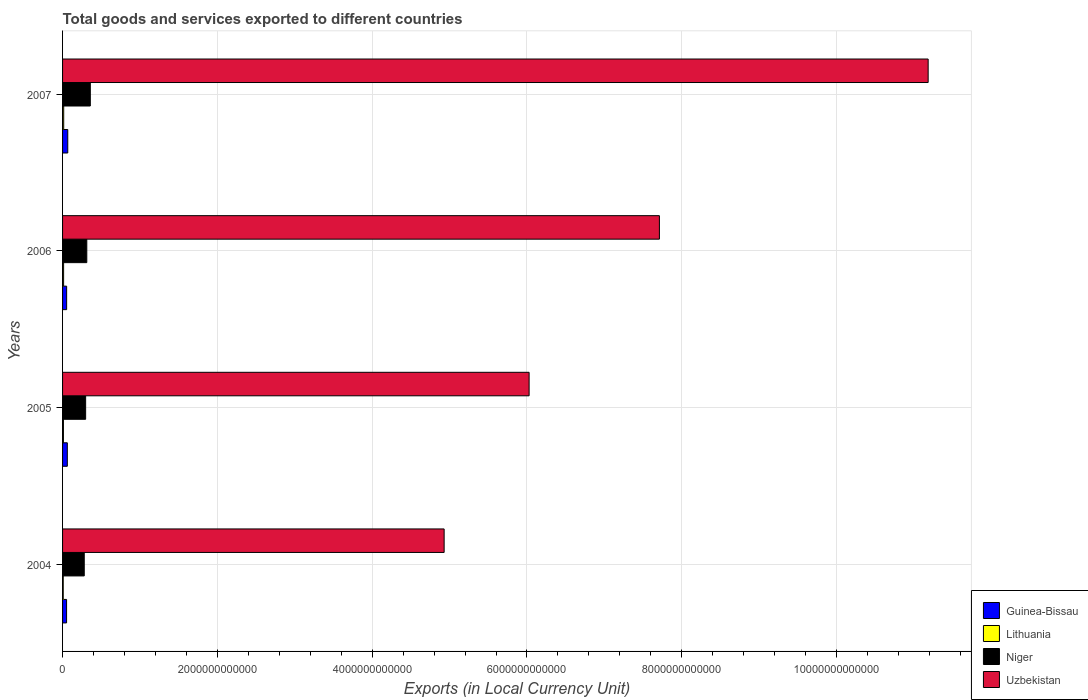Are the number of bars on each tick of the Y-axis equal?
Provide a succinct answer. Yes. How many bars are there on the 2nd tick from the bottom?
Ensure brevity in your answer.  4. What is the label of the 2nd group of bars from the top?
Offer a very short reply. 2006. What is the Amount of goods and services exports in Uzbekistan in 2007?
Your answer should be compact. 1.12e+13. Across all years, what is the maximum Amount of goods and services exports in Lithuania?
Offer a very short reply. 1.46e+1. Across all years, what is the minimum Amount of goods and services exports in Uzbekistan?
Your response must be concise. 4.93e+12. In which year was the Amount of goods and services exports in Lithuania maximum?
Your answer should be very brief. 2007. What is the total Amount of goods and services exports in Uzbekistan in the graph?
Provide a succinct answer. 2.99e+13. What is the difference between the Amount of goods and services exports in Uzbekistan in 2004 and that in 2007?
Your answer should be compact. -6.25e+12. What is the difference between the Amount of goods and services exports in Niger in 2004 and the Amount of goods and services exports in Guinea-Bissau in 2006?
Offer a terse response. 2.27e+11. What is the average Amount of goods and services exports in Uzbekistan per year?
Provide a short and direct response. 7.46e+12. In the year 2006, what is the difference between the Amount of goods and services exports in Guinea-Bissau and Amount of goods and services exports in Uzbekistan?
Make the answer very short. -7.66e+12. In how many years, is the Amount of goods and services exports in Lithuania greater than 9200000000000 LCU?
Your answer should be compact. 0. What is the ratio of the Amount of goods and services exports in Lithuania in 2004 to that in 2005?
Provide a short and direct response. 0.76. Is the Amount of goods and services exports in Niger in 2004 less than that in 2006?
Your answer should be very brief. Yes. Is the difference between the Amount of goods and services exports in Guinea-Bissau in 2005 and 2006 greater than the difference between the Amount of goods and services exports in Uzbekistan in 2005 and 2006?
Provide a short and direct response. Yes. What is the difference between the highest and the second highest Amount of goods and services exports in Uzbekistan?
Provide a short and direct response. 3.47e+12. What is the difference between the highest and the lowest Amount of goods and services exports in Lithuania?
Your answer should be very brief. 6.00e+09. In how many years, is the Amount of goods and services exports in Uzbekistan greater than the average Amount of goods and services exports in Uzbekistan taken over all years?
Offer a terse response. 2. Is the sum of the Amount of goods and services exports in Niger in 2006 and 2007 greater than the maximum Amount of goods and services exports in Uzbekistan across all years?
Ensure brevity in your answer.  No. Is it the case that in every year, the sum of the Amount of goods and services exports in Uzbekistan and Amount of goods and services exports in Guinea-Bissau is greater than the sum of Amount of goods and services exports in Niger and Amount of goods and services exports in Lithuania?
Your answer should be very brief. No. What does the 2nd bar from the top in 2005 represents?
Give a very brief answer. Niger. What does the 2nd bar from the bottom in 2006 represents?
Provide a succinct answer. Lithuania. How many years are there in the graph?
Keep it short and to the point. 4. What is the difference between two consecutive major ticks on the X-axis?
Your response must be concise. 2.00e+12. Does the graph contain any zero values?
Your answer should be compact. No. Does the graph contain grids?
Your answer should be very brief. Yes. Where does the legend appear in the graph?
Keep it short and to the point. Bottom right. What is the title of the graph?
Your answer should be compact. Total goods and services exported to different countries. Does "Mozambique" appear as one of the legend labels in the graph?
Provide a short and direct response. No. What is the label or title of the X-axis?
Offer a terse response. Exports (in Local Currency Unit). What is the Exports (in Local Currency Unit) of Guinea-Bissau in 2004?
Provide a succinct answer. 5.18e+1. What is the Exports (in Local Currency Unit) of Lithuania in 2004?
Keep it short and to the point. 8.64e+09. What is the Exports (in Local Currency Unit) in Niger in 2004?
Give a very brief answer. 2.80e+11. What is the Exports (in Local Currency Unit) of Uzbekistan in 2004?
Your answer should be compact. 4.93e+12. What is the Exports (in Local Currency Unit) in Guinea-Bissau in 2005?
Your answer should be very brief. 6.15e+1. What is the Exports (in Local Currency Unit) of Lithuania in 2005?
Your answer should be compact. 1.13e+1. What is the Exports (in Local Currency Unit) in Niger in 2005?
Offer a terse response. 2.98e+11. What is the Exports (in Local Currency Unit) in Uzbekistan in 2005?
Give a very brief answer. 6.03e+12. What is the Exports (in Local Currency Unit) in Guinea-Bissau in 2006?
Offer a very short reply. 5.27e+1. What is the Exports (in Local Currency Unit) in Lithuania in 2006?
Offer a very short reply. 1.34e+1. What is the Exports (in Local Currency Unit) of Niger in 2006?
Your answer should be very brief. 3.13e+11. What is the Exports (in Local Currency Unit) of Uzbekistan in 2006?
Your answer should be very brief. 7.71e+12. What is the Exports (in Local Currency Unit) of Guinea-Bissau in 2007?
Your response must be concise. 6.73e+1. What is the Exports (in Local Currency Unit) in Lithuania in 2007?
Keep it short and to the point. 1.46e+1. What is the Exports (in Local Currency Unit) in Niger in 2007?
Ensure brevity in your answer.  3.58e+11. What is the Exports (in Local Currency Unit) of Uzbekistan in 2007?
Your response must be concise. 1.12e+13. Across all years, what is the maximum Exports (in Local Currency Unit) of Guinea-Bissau?
Your answer should be compact. 6.73e+1. Across all years, what is the maximum Exports (in Local Currency Unit) in Lithuania?
Your answer should be very brief. 1.46e+1. Across all years, what is the maximum Exports (in Local Currency Unit) in Niger?
Ensure brevity in your answer.  3.58e+11. Across all years, what is the maximum Exports (in Local Currency Unit) of Uzbekistan?
Keep it short and to the point. 1.12e+13. Across all years, what is the minimum Exports (in Local Currency Unit) of Guinea-Bissau?
Provide a succinct answer. 5.18e+1. Across all years, what is the minimum Exports (in Local Currency Unit) of Lithuania?
Provide a succinct answer. 8.64e+09. Across all years, what is the minimum Exports (in Local Currency Unit) in Niger?
Your response must be concise. 2.80e+11. Across all years, what is the minimum Exports (in Local Currency Unit) of Uzbekistan?
Offer a terse response. 4.93e+12. What is the total Exports (in Local Currency Unit) of Guinea-Bissau in the graph?
Provide a succinct answer. 2.33e+11. What is the total Exports (in Local Currency Unit) of Lithuania in the graph?
Make the answer very short. 4.80e+1. What is the total Exports (in Local Currency Unit) of Niger in the graph?
Your response must be concise. 1.25e+12. What is the total Exports (in Local Currency Unit) of Uzbekistan in the graph?
Provide a short and direct response. 2.99e+13. What is the difference between the Exports (in Local Currency Unit) of Guinea-Bissau in 2004 and that in 2005?
Give a very brief answer. -9.66e+09. What is the difference between the Exports (in Local Currency Unit) in Lithuania in 2004 and that in 2005?
Your answer should be compact. -2.68e+09. What is the difference between the Exports (in Local Currency Unit) of Niger in 2004 and that in 2005?
Give a very brief answer. -1.80e+1. What is the difference between the Exports (in Local Currency Unit) in Uzbekistan in 2004 and that in 2005?
Your answer should be very brief. -1.10e+12. What is the difference between the Exports (in Local Currency Unit) of Guinea-Bissau in 2004 and that in 2006?
Make the answer very short. -9.06e+08. What is the difference between the Exports (in Local Currency Unit) of Lithuania in 2004 and that in 2006?
Your answer should be compact. -4.77e+09. What is the difference between the Exports (in Local Currency Unit) of Niger in 2004 and that in 2006?
Offer a terse response. -3.29e+1. What is the difference between the Exports (in Local Currency Unit) in Uzbekistan in 2004 and that in 2006?
Offer a very short reply. -2.78e+12. What is the difference between the Exports (in Local Currency Unit) of Guinea-Bissau in 2004 and that in 2007?
Provide a succinct answer. -1.55e+1. What is the difference between the Exports (in Local Currency Unit) of Lithuania in 2004 and that in 2007?
Keep it short and to the point. -6.00e+09. What is the difference between the Exports (in Local Currency Unit) of Niger in 2004 and that in 2007?
Keep it short and to the point. -7.84e+1. What is the difference between the Exports (in Local Currency Unit) in Uzbekistan in 2004 and that in 2007?
Your response must be concise. -6.25e+12. What is the difference between the Exports (in Local Currency Unit) in Guinea-Bissau in 2005 and that in 2006?
Your response must be concise. 8.75e+09. What is the difference between the Exports (in Local Currency Unit) of Lithuania in 2005 and that in 2006?
Your answer should be very brief. -2.09e+09. What is the difference between the Exports (in Local Currency Unit) of Niger in 2005 and that in 2006?
Keep it short and to the point. -1.49e+1. What is the difference between the Exports (in Local Currency Unit) of Uzbekistan in 2005 and that in 2006?
Offer a terse response. -1.68e+12. What is the difference between the Exports (in Local Currency Unit) of Guinea-Bissau in 2005 and that in 2007?
Provide a short and direct response. -5.81e+09. What is the difference between the Exports (in Local Currency Unit) in Lithuania in 2005 and that in 2007?
Give a very brief answer. -3.32e+09. What is the difference between the Exports (in Local Currency Unit) in Niger in 2005 and that in 2007?
Provide a short and direct response. -6.04e+1. What is the difference between the Exports (in Local Currency Unit) of Uzbekistan in 2005 and that in 2007?
Provide a succinct answer. -5.16e+12. What is the difference between the Exports (in Local Currency Unit) of Guinea-Bissau in 2006 and that in 2007?
Provide a short and direct response. -1.46e+1. What is the difference between the Exports (in Local Currency Unit) in Lithuania in 2006 and that in 2007?
Your answer should be very brief. -1.23e+09. What is the difference between the Exports (in Local Currency Unit) in Niger in 2006 and that in 2007?
Your response must be concise. -4.55e+1. What is the difference between the Exports (in Local Currency Unit) of Uzbekistan in 2006 and that in 2007?
Ensure brevity in your answer.  -3.47e+12. What is the difference between the Exports (in Local Currency Unit) in Guinea-Bissau in 2004 and the Exports (in Local Currency Unit) in Lithuania in 2005?
Keep it short and to the point. 4.05e+1. What is the difference between the Exports (in Local Currency Unit) of Guinea-Bissau in 2004 and the Exports (in Local Currency Unit) of Niger in 2005?
Keep it short and to the point. -2.46e+11. What is the difference between the Exports (in Local Currency Unit) of Guinea-Bissau in 2004 and the Exports (in Local Currency Unit) of Uzbekistan in 2005?
Provide a succinct answer. -5.98e+12. What is the difference between the Exports (in Local Currency Unit) in Lithuania in 2004 and the Exports (in Local Currency Unit) in Niger in 2005?
Your answer should be compact. -2.89e+11. What is the difference between the Exports (in Local Currency Unit) of Lithuania in 2004 and the Exports (in Local Currency Unit) of Uzbekistan in 2005?
Give a very brief answer. -6.02e+12. What is the difference between the Exports (in Local Currency Unit) in Niger in 2004 and the Exports (in Local Currency Unit) in Uzbekistan in 2005?
Make the answer very short. -5.75e+12. What is the difference between the Exports (in Local Currency Unit) in Guinea-Bissau in 2004 and the Exports (in Local Currency Unit) in Lithuania in 2006?
Your answer should be very brief. 3.84e+1. What is the difference between the Exports (in Local Currency Unit) in Guinea-Bissau in 2004 and the Exports (in Local Currency Unit) in Niger in 2006?
Your answer should be compact. -2.61e+11. What is the difference between the Exports (in Local Currency Unit) in Guinea-Bissau in 2004 and the Exports (in Local Currency Unit) in Uzbekistan in 2006?
Give a very brief answer. -7.66e+12. What is the difference between the Exports (in Local Currency Unit) in Lithuania in 2004 and the Exports (in Local Currency Unit) in Niger in 2006?
Your response must be concise. -3.04e+11. What is the difference between the Exports (in Local Currency Unit) of Lithuania in 2004 and the Exports (in Local Currency Unit) of Uzbekistan in 2006?
Provide a succinct answer. -7.70e+12. What is the difference between the Exports (in Local Currency Unit) in Niger in 2004 and the Exports (in Local Currency Unit) in Uzbekistan in 2006?
Offer a very short reply. -7.43e+12. What is the difference between the Exports (in Local Currency Unit) of Guinea-Bissau in 2004 and the Exports (in Local Currency Unit) of Lithuania in 2007?
Your answer should be compact. 3.72e+1. What is the difference between the Exports (in Local Currency Unit) in Guinea-Bissau in 2004 and the Exports (in Local Currency Unit) in Niger in 2007?
Your answer should be very brief. -3.07e+11. What is the difference between the Exports (in Local Currency Unit) in Guinea-Bissau in 2004 and the Exports (in Local Currency Unit) in Uzbekistan in 2007?
Provide a succinct answer. -1.11e+13. What is the difference between the Exports (in Local Currency Unit) of Lithuania in 2004 and the Exports (in Local Currency Unit) of Niger in 2007?
Provide a succinct answer. -3.50e+11. What is the difference between the Exports (in Local Currency Unit) of Lithuania in 2004 and the Exports (in Local Currency Unit) of Uzbekistan in 2007?
Offer a terse response. -1.12e+13. What is the difference between the Exports (in Local Currency Unit) of Niger in 2004 and the Exports (in Local Currency Unit) of Uzbekistan in 2007?
Provide a short and direct response. -1.09e+13. What is the difference between the Exports (in Local Currency Unit) of Guinea-Bissau in 2005 and the Exports (in Local Currency Unit) of Lithuania in 2006?
Provide a succinct answer. 4.80e+1. What is the difference between the Exports (in Local Currency Unit) of Guinea-Bissau in 2005 and the Exports (in Local Currency Unit) of Niger in 2006?
Your response must be concise. -2.52e+11. What is the difference between the Exports (in Local Currency Unit) of Guinea-Bissau in 2005 and the Exports (in Local Currency Unit) of Uzbekistan in 2006?
Make the answer very short. -7.65e+12. What is the difference between the Exports (in Local Currency Unit) of Lithuania in 2005 and the Exports (in Local Currency Unit) of Niger in 2006?
Make the answer very short. -3.02e+11. What is the difference between the Exports (in Local Currency Unit) in Lithuania in 2005 and the Exports (in Local Currency Unit) in Uzbekistan in 2006?
Ensure brevity in your answer.  -7.70e+12. What is the difference between the Exports (in Local Currency Unit) of Niger in 2005 and the Exports (in Local Currency Unit) of Uzbekistan in 2006?
Offer a terse response. -7.41e+12. What is the difference between the Exports (in Local Currency Unit) in Guinea-Bissau in 2005 and the Exports (in Local Currency Unit) in Lithuania in 2007?
Your answer should be very brief. 4.68e+1. What is the difference between the Exports (in Local Currency Unit) of Guinea-Bissau in 2005 and the Exports (in Local Currency Unit) of Niger in 2007?
Provide a short and direct response. -2.97e+11. What is the difference between the Exports (in Local Currency Unit) in Guinea-Bissau in 2005 and the Exports (in Local Currency Unit) in Uzbekistan in 2007?
Provide a succinct answer. -1.11e+13. What is the difference between the Exports (in Local Currency Unit) in Lithuania in 2005 and the Exports (in Local Currency Unit) in Niger in 2007?
Offer a very short reply. -3.47e+11. What is the difference between the Exports (in Local Currency Unit) in Lithuania in 2005 and the Exports (in Local Currency Unit) in Uzbekistan in 2007?
Give a very brief answer. -1.12e+13. What is the difference between the Exports (in Local Currency Unit) of Niger in 2005 and the Exports (in Local Currency Unit) of Uzbekistan in 2007?
Give a very brief answer. -1.09e+13. What is the difference between the Exports (in Local Currency Unit) in Guinea-Bissau in 2006 and the Exports (in Local Currency Unit) in Lithuania in 2007?
Offer a very short reply. 3.81e+1. What is the difference between the Exports (in Local Currency Unit) in Guinea-Bissau in 2006 and the Exports (in Local Currency Unit) in Niger in 2007?
Keep it short and to the point. -3.06e+11. What is the difference between the Exports (in Local Currency Unit) in Guinea-Bissau in 2006 and the Exports (in Local Currency Unit) in Uzbekistan in 2007?
Provide a short and direct response. -1.11e+13. What is the difference between the Exports (in Local Currency Unit) in Lithuania in 2006 and the Exports (in Local Currency Unit) in Niger in 2007?
Keep it short and to the point. -3.45e+11. What is the difference between the Exports (in Local Currency Unit) in Lithuania in 2006 and the Exports (in Local Currency Unit) in Uzbekistan in 2007?
Keep it short and to the point. -1.12e+13. What is the difference between the Exports (in Local Currency Unit) of Niger in 2006 and the Exports (in Local Currency Unit) of Uzbekistan in 2007?
Give a very brief answer. -1.09e+13. What is the average Exports (in Local Currency Unit) in Guinea-Bissau per year?
Offer a very short reply. 5.83e+1. What is the average Exports (in Local Currency Unit) in Lithuania per year?
Your answer should be compact. 1.20e+1. What is the average Exports (in Local Currency Unit) of Niger per year?
Keep it short and to the point. 3.12e+11. What is the average Exports (in Local Currency Unit) in Uzbekistan per year?
Offer a very short reply. 7.46e+12. In the year 2004, what is the difference between the Exports (in Local Currency Unit) of Guinea-Bissau and Exports (in Local Currency Unit) of Lithuania?
Provide a short and direct response. 4.32e+1. In the year 2004, what is the difference between the Exports (in Local Currency Unit) in Guinea-Bissau and Exports (in Local Currency Unit) in Niger?
Your answer should be very brief. -2.28e+11. In the year 2004, what is the difference between the Exports (in Local Currency Unit) of Guinea-Bissau and Exports (in Local Currency Unit) of Uzbekistan?
Give a very brief answer. -4.88e+12. In the year 2004, what is the difference between the Exports (in Local Currency Unit) of Lithuania and Exports (in Local Currency Unit) of Niger?
Offer a very short reply. -2.71e+11. In the year 2004, what is the difference between the Exports (in Local Currency Unit) in Lithuania and Exports (in Local Currency Unit) in Uzbekistan?
Make the answer very short. -4.92e+12. In the year 2004, what is the difference between the Exports (in Local Currency Unit) in Niger and Exports (in Local Currency Unit) in Uzbekistan?
Keep it short and to the point. -4.65e+12. In the year 2005, what is the difference between the Exports (in Local Currency Unit) of Guinea-Bissau and Exports (in Local Currency Unit) of Lithuania?
Provide a succinct answer. 5.01e+1. In the year 2005, what is the difference between the Exports (in Local Currency Unit) in Guinea-Bissau and Exports (in Local Currency Unit) in Niger?
Make the answer very short. -2.37e+11. In the year 2005, what is the difference between the Exports (in Local Currency Unit) of Guinea-Bissau and Exports (in Local Currency Unit) of Uzbekistan?
Keep it short and to the point. -5.97e+12. In the year 2005, what is the difference between the Exports (in Local Currency Unit) in Lithuania and Exports (in Local Currency Unit) in Niger?
Your response must be concise. -2.87e+11. In the year 2005, what is the difference between the Exports (in Local Currency Unit) of Lithuania and Exports (in Local Currency Unit) of Uzbekistan?
Give a very brief answer. -6.02e+12. In the year 2005, what is the difference between the Exports (in Local Currency Unit) of Niger and Exports (in Local Currency Unit) of Uzbekistan?
Give a very brief answer. -5.73e+12. In the year 2006, what is the difference between the Exports (in Local Currency Unit) in Guinea-Bissau and Exports (in Local Currency Unit) in Lithuania?
Offer a very short reply. 3.93e+1. In the year 2006, what is the difference between the Exports (in Local Currency Unit) of Guinea-Bissau and Exports (in Local Currency Unit) of Niger?
Your response must be concise. -2.60e+11. In the year 2006, what is the difference between the Exports (in Local Currency Unit) in Guinea-Bissau and Exports (in Local Currency Unit) in Uzbekistan?
Your response must be concise. -7.66e+12. In the year 2006, what is the difference between the Exports (in Local Currency Unit) of Lithuania and Exports (in Local Currency Unit) of Niger?
Offer a very short reply. -3.00e+11. In the year 2006, what is the difference between the Exports (in Local Currency Unit) of Lithuania and Exports (in Local Currency Unit) of Uzbekistan?
Ensure brevity in your answer.  -7.70e+12. In the year 2006, what is the difference between the Exports (in Local Currency Unit) in Niger and Exports (in Local Currency Unit) in Uzbekistan?
Provide a short and direct response. -7.40e+12. In the year 2007, what is the difference between the Exports (in Local Currency Unit) of Guinea-Bissau and Exports (in Local Currency Unit) of Lithuania?
Offer a terse response. 5.26e+1. In the year 2007, what is the difference between the Exports (in Local Currency Unit) in Guinea-Bissau and Exports (in Local Currency Unit) in Niger?
Your response must be concise. -2.91e+11. In the year 2007, what is the difference between the Exports (in Local Currency Unit) in Guinea-Bissau and Exports (in Local Currency Unit) in Uzbekistan?
Your answer should be very brief. -1.11e+13. In the year 2007, what is the difference between the Exports (in Local Currency Unit) of Lithuania and Exports (in Local Currency Unit) of Niger?
Your response must be concise. -3.44e+11. In the year 2007, what is the difference between the Exports (in Local Currency Unit) in Lithuania and Exports (in Local Currency Unit) in Uzbekistan?
Provide a short and direct response. -1.12e+13. In the year 2007, what is the difference between the Exports (in Local Currency Unit) in Niger and Exports (in Local Currency Unit) in Uzbekistan?
Your answer should be very brief. -1.08e+13. What is the ratio of the Exports (in Local Currency Unit) of Guinea-Bissau in 2004 to that in 2005?
Give a very brief answer. 0.84. What is the ratio of the Exports (in Local Currency Unit) in Lithuania in 2004 to that in 2005?
Your response must be concise. 0.76. What is the ratio of the Exports (in Local Currency Unit) in Niger in 2004 to that in 2005?
Give a very brief answer. 0.94. What is the ratio of the Exports (in Local Currency Unit) of Uzbekistan in 2004 to that in 2005?
Offer a terse response. 0.82. What is the ratio of the Exports (in Local Currency Unit) in Guinea-Bissau in 2004 to that in 2006?
Ensure brevity in your answer.  0.98. What is the ratio of the Exports (in Local Currency Unit) in Lithuania in 2004 to that in 2006?
Give a very brief answer. 0.64. What is the ratio of the Exports (in Local Currency Unit) of Niger in 2004 to that in 2006?
Make the answer very short. 0.89. What is the ratio of the Exports (in Local Currency Unit) in Uzbekistan in 2004 to that in 2006?
Keep it short and to the point. 0.64. What is the ratio of the Exports (in Local Currency Unit) of Guinea-Bissau in 2004 to that in 2007?
Provide a short and direct response. 0.77. What is the ratio of the Exports (in Local Currency Unit) in Lithuania in 2004 to that in 2007?
Keep it short and to the point. 0.59. What is the ratio of the Exports (in Local Currency Unit) in Niger in 2004 to that in 2007?
Keep it short and to the point. 0.78. What is the ratio of the Exports (in Local Currency Unit) in Uzbekistan in 2004 to that in 2007?
Give a very brief answer. 0.44. What is the ratio of the Exports (in Local Currency Unit) of Guinea-Bissau in 2005 to that in 2006?
Your answer should be compact. 1.17. What is the ratio of the Exports (in Local Currency Unit) in Lithuania in 2005 to that in 2006?
Make the answer very short. 0.84. What is the ratio of the Exports (in Local Currency Unit) of Niger in 2005 to that in 2006?
Ensure brevity in your answer.  0.95. What is the ratio of the Exports (in Local Currency Unit) in Uzbekistan in 2005 to that in 2006?
Offer a very short reply. 0.78. What is the ratio of the Exports (in Local Currency Unit) of Guinea-Bissau in 2005 to that in 2007?
Your answer should be very brief. 0.91. What is the ratio of the Exports (in Local Currency Unit) of Lithuania in 2005 to that in 2007?
Keep it short and to the point. 0.77. What is the ratio of the Exports (in Local Currency Unit) in Niger in 2005 to that in 2007?
Your answer should be compact. 0.83. What is the ratio of the Exports (in Local Currency Unit) in Uzbekistan in 2005 to that in 2007?
Offer a terse response. 0.54. What is the ratio of the Exports (in Local Currency Unit) of Guinea-Bissau in 2006 to that in 2007?
Make the answer very short. 0.78. What is the ratio of the Exports (in Local Currency Unit) in Lithuania in 2006 to that in 2007?
Ensure brevity in your answer.  0.92. What is the ratio of the Exports (in Local Currency Unit) in Niger in 2006 to that in 2007?
Offer a very short reply. 0.87. What is the ratio of the Exports (in Local Currency Unit) of Uzbekistan in 2006 to that in 2007?
Give a very brief answer. 0.69. What is the difference between the highest and the second highest Exports (in Local Currency Unit) of Guinea-Bissau?
Give a very brief answer. 5.81e+09. What is the difference between the highest and the second highest Exports (in Local Currency Unit) of Lithuania?
Your answer should be compact. 1.23e+09. What is the difference between the highest and the second highest Exports (in Local Currency Unit) in Niger?
Offer a very short reply. 4.55e+1. What is the difference between the highest and the second highest Exports (in Local Currency Unit) of Uzbekistan?
Provide a short and direct response. 3.47e+12. What is the difference between the highest and the lowest Exports (in Local Currency Unit) of Guinea-Bissau?
Your answer should be very brief. 1.55e+1. What is the difference between the highest and the lowest Exports (in Local Currency Unit) in Lithuania?
Offer a terse response. 6.00e+09. What is the difference between the highest and the lowest Exports (in Local Currency Unit) of Niger?
Offer a very short reply. 7.84e+1. What is the difference between the highest and the lowest Exports (in Local Currency Unit) in Uzbekistan?
Your response must be concise. 6.25e+12. 